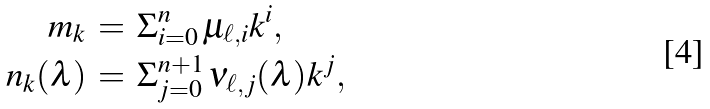Convert formula to latex. <formula><loc_0><loc_0><loc_500><loc_500>m _ { k } \, & = \, \Sigma _ { i = 0 } ^ { n } \, \mu _ { \ell , i } k ^ { i } , \\ n _ { k } ( \lambda ) \, & = \, \Sigma _ { j = 0 } ^ { n + 1 } \, \nu _ { \ell , j } ( \lambda ) k ^ { j } ,</formula> 